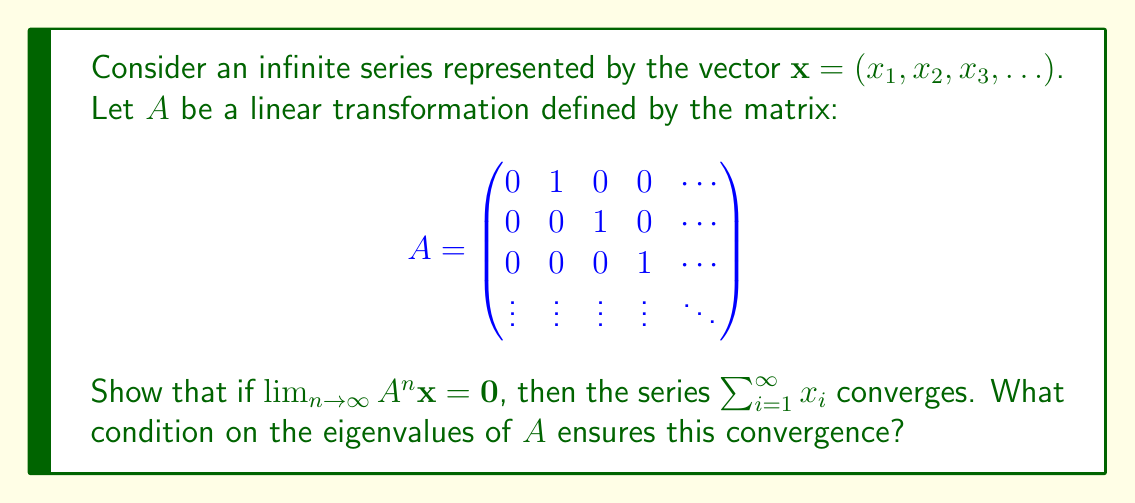What is the answer to this math problem? To approach this problem, we'll use linear algebra techniques to analyze the convergence of the infinite series:

1) First, let's consider the effect of $A^n$ on $\mathbf{x}$:

   $A\mathbf{x} = (x_2, x_3, x_4, \ldots)$
   $A^2\mathbf{x} = (x_3, x_4, x_5, \ldots)$
   $A^n\mathbf{x} = (x_{n+1}, x_{n+2}, x_{n+3}, \ldots)$

2) If $\lim_{n \to \infty} A^n \mathbf{x} = \mathbf{0}$, this means:

   $\lim_{n \to \infty} x_n = 0$

3) This is a necessary condition for the convergence of $\sum_{i=1}^{\infty} x_i$. However, it's not sufficient. We need to use the Cauchy criterion for series convergence.

4) The series $\sum_{i=1}^{\infty} x_i$ converges if and only if for every $\epsilon > 0$, there exists an $N$ such that for all $m > n > N$:

   $|\sum_{i=n+1}^m x_i| < \epsilon$

5) We can represent this partial sum using our linear transformation:

   $\sum_{i=n+1}^m x_i = \mathbf{e}_1^T(A^n - A^m)\mathbf{x}$

   where $\mathbf{e}_1 = (1, 0, 0, \ldots)$ is the first standard basis vector.

6) If $\lim_{n \to \infty} A^n \mathbf{x} = \mathbf{0}$, then for any $\epsilon > 0$, we can find an $N$ such that for all $n > N$:

   $\|A^n \mathbf{x}\| < \epsilon$

7) This implies that for $m > n > N$:

   $|\sum_{i=n+1}^m x_i| = |\mathbf{e}_1^T(A^n - A^m)\mathbf{x}| \leq \|A^n \mathbf{x}\| + \|A^m \mathbf{x}\| < 2\epsilon$

8) This satisfies the Cauchy criterion, proving that the series converges.

9) For the condition on eigenvalues, we know that $\lim_{n \to \infty} A^n = 0$ if and only if all eigenvalues $\lambda$ of $A$ satisfy $|\lambda| < 1$. This condition ensures that $\lim_{n \to \infty} A^n \mathbf{x} = \mathbf{0}$ for any initial vector $\mathbf{x}$.
Answer: If $\lim_{n \to \infty} A^n \mathbf{x} = \mathbf{0}$, then the series $\sum_{i=1}^{\infty} x_i$ converges. The condition on the eigenvalues of $A$ that ensures this convergence is that all eigenvalues $\lambda$ of $A$ must satisfy $|\lambda| < 1$. 